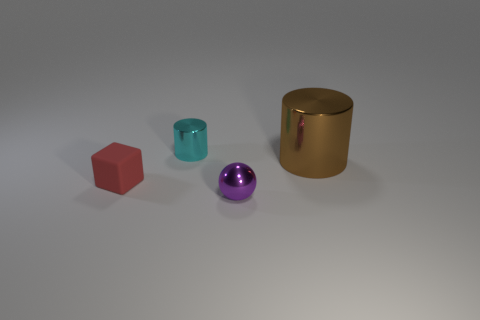How many objects are there in this image, and can you describe their shapes and colors? In the image, there are four objects. Starting from the left, there's a red cube, a teal cylinder, a shiny purple sphere, and a large gold cylinder. 